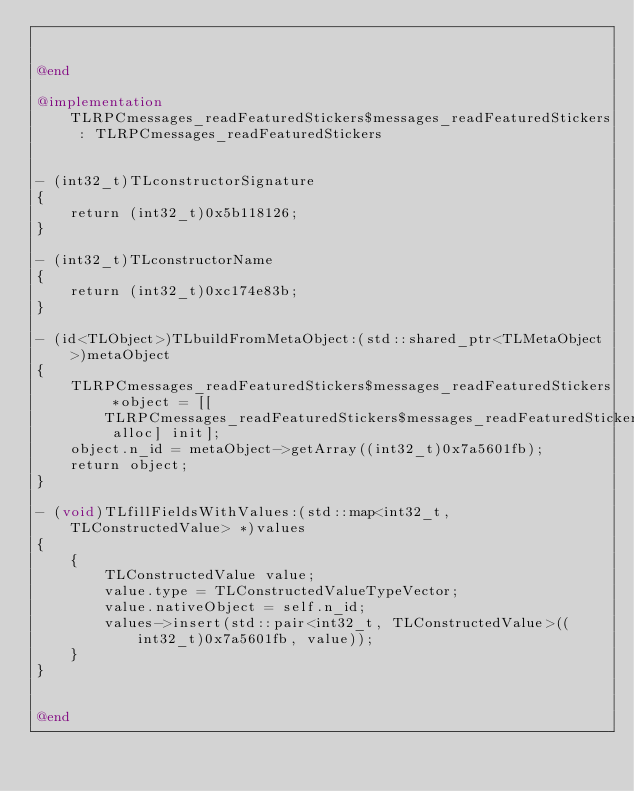<code> <loc_0><loc_0><loc_500><loc_500><_ObjectiveC_>

@end

@implementation TLRPCmessages_readFeaturedStickers$messages_readFeaturedStickers : TLRPCmessages_readFeaturedStickers


- (int32_t)TLconstructorSignature
{
    return (int32_t)0x5b118126;
}

- (int32_t)TLconstructorName
{
    return (int32_t)0xc174e83b;
}

- (id<TLObject>)TLbuildFromMetaObject:(std::shared_ptr<TLMetaObject>)metaObject
{
    TLRPCmessages_readFeaturedStickers$messages_readFeaturedStickers *object = [[TLRPCmessages_readFeaturedStickers$messages_readFeaturedStickers alloc] init];
    object.n_id = metaObject->getArray((int32_t)0x7a5601fb);
    return object;
}

- (void)TLfillFieldsWithValues:(std::map<int32_t, TLConstructedValue> *)values
{
    {
        TLConstructedValue value;
        value.type = TLConstructedValueTypeVector;
        value.nativeObject = self.n_id;
        values->insert(std::pair<int32_t, TLConstructedValue>((int32_t)0x7a5601fb, value));
    }
}


@end

</code> 